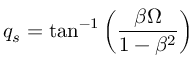Convert formula to latex. <formula><loc_0><loc_0><loc_500><loc_500>q _ { s } = \tan ^ { - 1 } \left ( \frac { \beta \Omega } { 1 - \beta ^ { 2 } } \right )</formula> 